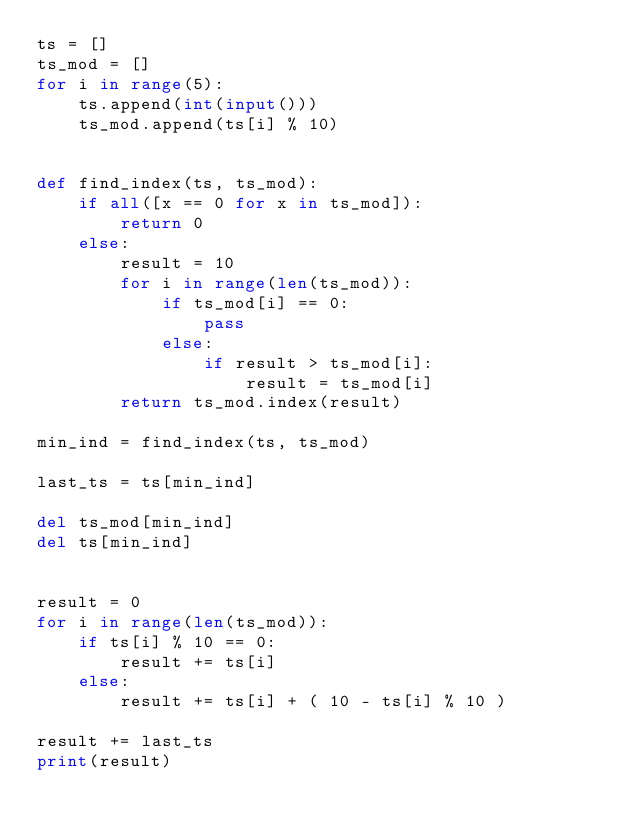Convert code to text. <code><loc_0><loc_0><loc_500><loc_500><_Python_>ts = []
ts_mod = []
for i in range(5):
    ts.append(int(input()))
    ts_mod.append(ts[i] % 10)


def find_index(ts, ts_mod):
    if all([x == 0 for x in ts_mod]):
        return 0
    else:
        result = 10
        for i in range(len(ts_mod)):
            if ts_mod[i] == 0:
                pass
            else:
                if result > ts_mod[i]:
                    result = ts_mod[i]
        return ts_mod.index(result)

min_ind = find_index(ts, ts_mod)

last_ts = ts[min_ind]

del ts_mod[min_ind]
del ts[min_ind]


result = 0
for i in range(len(ts_mod)):
    if ts[i] % 10 == 0:
        result += ts[i]
    else:
        result += ts[i] + ( 10 - ts[i] % 10 )
        
result += last_ts
print(result)</code> 